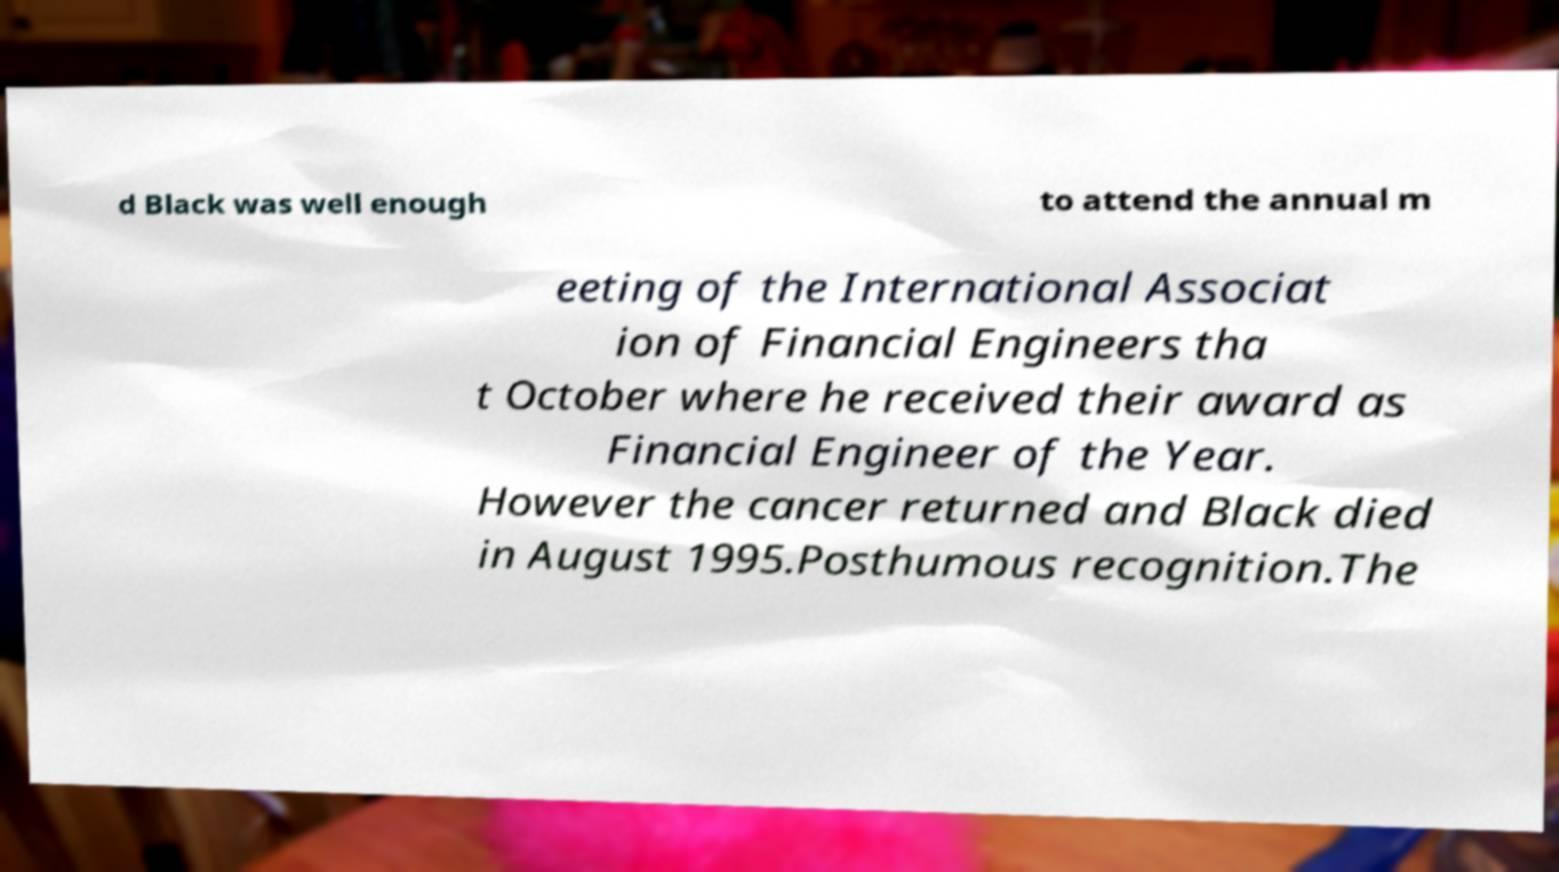There's text embedded in this image that I need extracted. Can you transcribe it verbatim? d Black was well enough to attend the annual m eeting of the International Associat ion of Financial Engineers tha t October where he received their award as Financial Engineer of the Year. However the cancer returned and Black died in August 1995.Posthumous recognition.The 